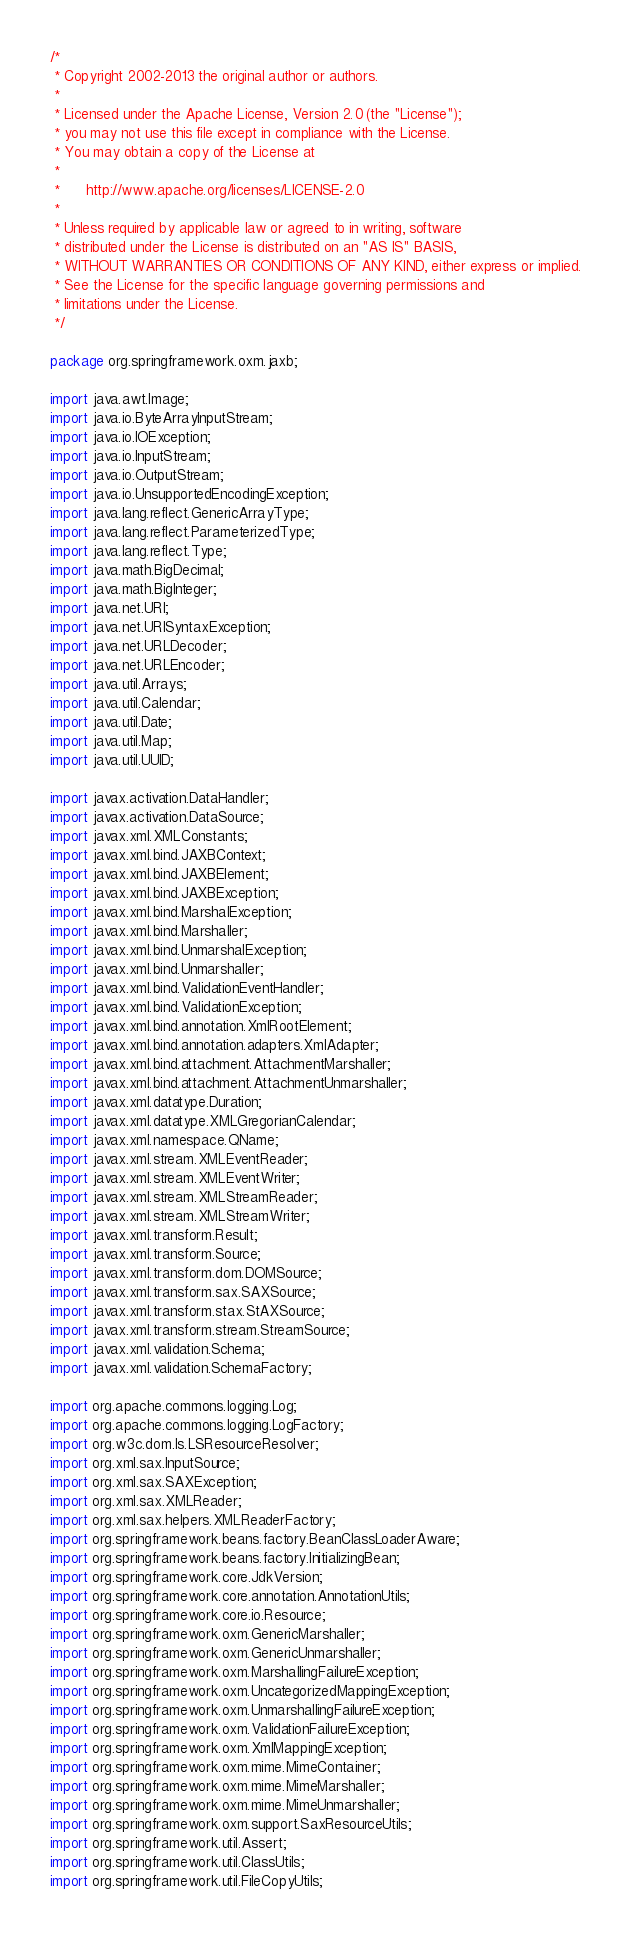Convert code to text. <code><loc_0><loc_0><loc_500><loc_500><_Java_>/*
 * Copyright 2002-2013 the original author or authors.
 *
 * Licensed under the Apache License, Version 2.0 (the "License");
 * you may not use this file except in compliance with the License.
 * You may obtain a copy of the License at
 *
 *      http://www.apache.org/licenses/LICENSE-2.0
 *
 * Unless required by applicable law or agreed to in writing, software
 * distributed under the License is distributed on an "AS IS" BASIS,
 * WITHOUT WARRANTIES OR CONDITIONS OF ANY KIND, either express or implied.
 * See the License for the specific language governing permissions and
 * limitations under the License.
 */

package org.springframework.oxm.jaxb;

import java.awt.Image;
import java.io.ByteArrayInputStream;
import java.io.IOException;
import java.io.InputStream;
import java.io.OutputStream;
import java.io.UnsupportedEncodingException;
import java.lang.reflect.GenericArrayType;
import java.lang.reflect.ParameterizedType;
import java.lang.reflect.Type;
import java.math.BigDecimal;
import java.math.BigInteger;
import java.net.URI;
import java.net.URISyntaxException;
import java.net.URLDecoder;
import java.net.URLEncoder;
import java.util.Arrays;
import java.util.Calendar;
import java.util.Date;
import java.util.Map;
import java.util.UUID;

import javax.activation.DataHandler;
import javax.activation.DataSource;
import javax.xml.XMLConstants;
import javax.xml.bind.JAXBContext;
import javax.xml.bind.JAXBElement;
import javax.xml.bind.JAXBException;
import javax.xml.bind.MarshalException;
import javax.xml.bind.Marshaller;
import javax.xml.bind.UnmarshalException;
import javax.xml.bind.Unmarshaller;
import javax.xml.bind.ValidationEventHandler;
import javax.xml.bind.ValidationException;
import javax.xml.bind.annotation.XmlRootElement;
import javax.xml.bind.annotation.adapters.XmlAdapter;
import javax.xml.bind.attachment.AttachmentMarshaller;
import javax.xml.bind.attachment.AttachmentUnmarshaller;
import javax.xml.datatype.Duration;
import javax.xml.datatype.XMLGregorianCalendar;
import javax.xml.namespace.QName;
import javax.xml.stream.XMLEventReader;
import javax.xml.stream.XMLEventWriter;
import javax.xml.stream.XMLStreamReader;
import javax.xml.stream.XMLStreamWriter;
import javax.xml.transform.Result;
import javax.xml.transform.Source;
import javax.xml.transform.dom.DOMSource;
import javax.xml.transform.sax.SAXSource;
import javax.xml.transform.stax.StAXSource;
import javax.xml.transform.stream.StreamSource;
import javax.xml.validation.Schema;
import javax.xml.validation.SchemaFactory;

import org.apache.commons.logging.Log;
import org.apache.commons.logging.LogFactory;
import org.w3c.dom.ls.LSResourceResolver;
import org.xml.sax.InputSource;
import org.xml.sax.SAXException;
import org.xml.sax.XMLReader;
import org.xml.sax.helpers.XMLReaderFactory;
import org.springframework.beans.factory.BeanClassLoaderAware;
import org.springframework.beans.factory.InitializingBean;
import org.springframework.core.JdkVersion;
import org.springframework.core.annotation.AnnotationUtils;
import org.springframework.core.io.Resource;
import org.springframework.oxm.GenericMarshaller;
import org.springframework.oxm.GenericUnmarshaller;
import org.springframework.oxm.MarshallingFailureException;
import org.springframework.oxm.UncategorizedMappingException;
import org.springframework.oxm.UnmarshallingFailureException;
import org.springframework.oxm.ValidationFailureException;
import org.springframework.oxm.XmlMappingException;
import org.springframework.oxm.mime.MimeContainer;
import org.springframework.oxm.mime.MimeMarshaller;
import org.springframework.oxm.mime.MimeUnmarshaller;
import org.springframework.oxm.support.SaxResourceUtils;
import org.springframework.util.Assert;
import org.springframework.util.ClassUtils;
import org.springframework.util.FileCopyUtils;</code> 